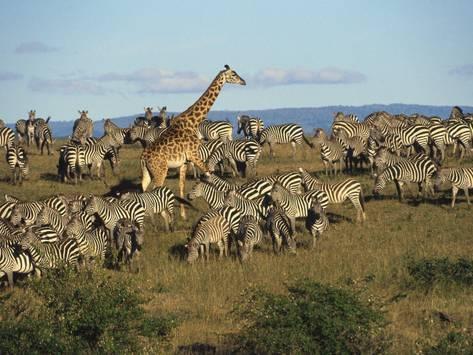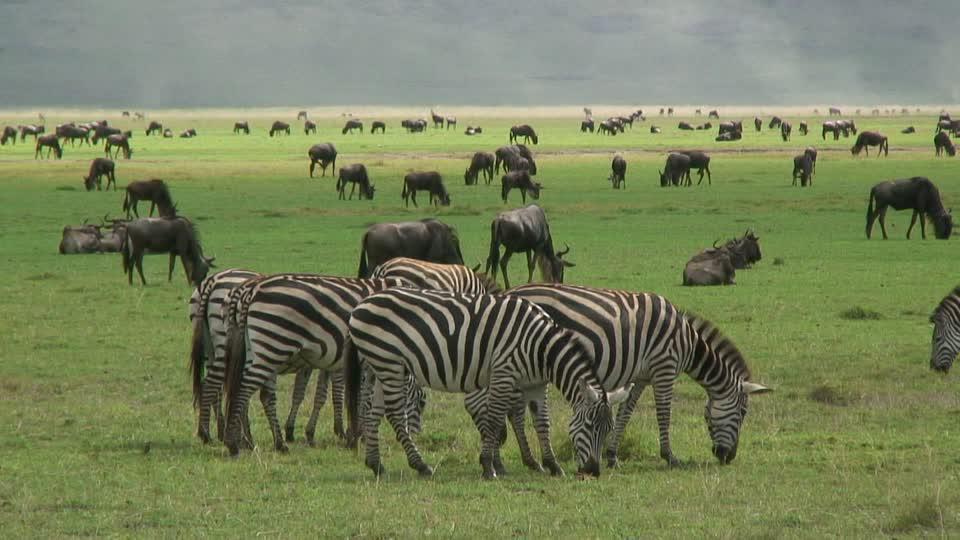The first image is the image on the left, the second image is the image on the right. Evaluate the accuracy of this statement regarding the images: "The right image shows dark hooved animals grazing behind zebra, and the left image shows zebra in a field with no watering hole visible.". Is it true? Answer yes or no. Yes. The first image is the image on the left, the second image is the image on the right. Examine the images to the left and right. Is the description "There are clouds visible in the left image." accurate? Answer yes or no. Yes. 